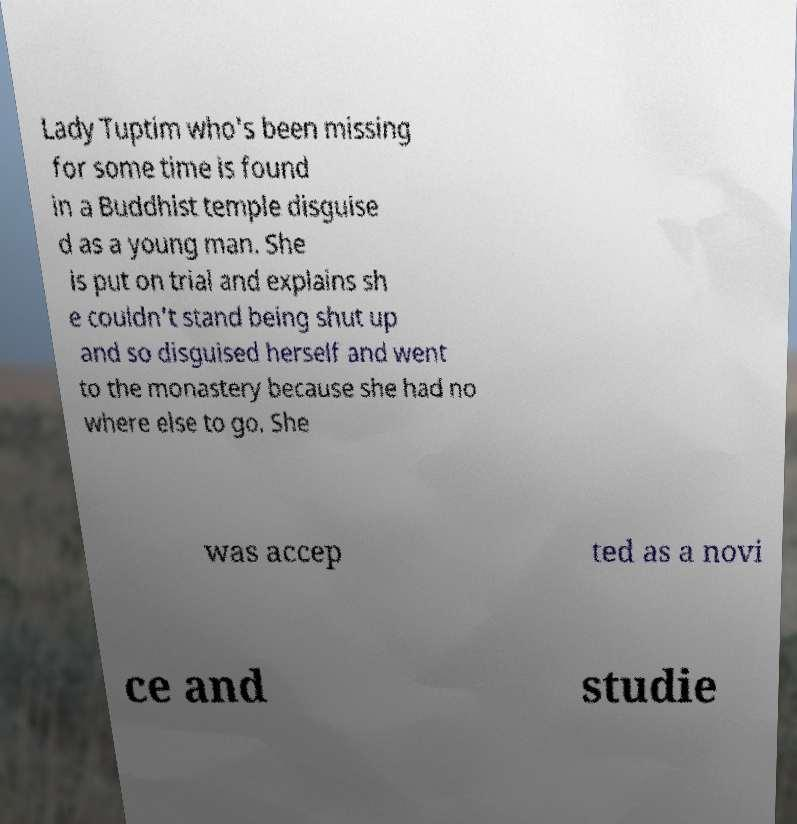I need the written content from this picture converted into text. Can you do that? Lady Tuptim who's been missing for some time is found in a Buddhist temple disguise d as a young man. She is put on trial and explains sh e couldn't stand being shut up and so disguised herself and went to the monastery because she had no where else to go. She was accep ted as a novi ce and studie 